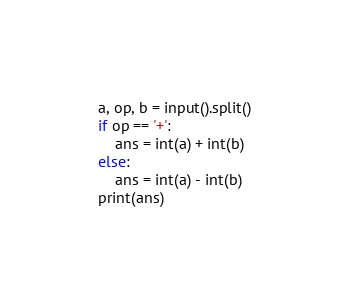Convert code to text. <code><loc_0><loc_0><loc_500><loc_500><_Python_>a, op, b = input().split()
if op == '+':
    ans = int(a) + int(b)
else:
    ans = int(a) - int(b)
print(ans)</code> 